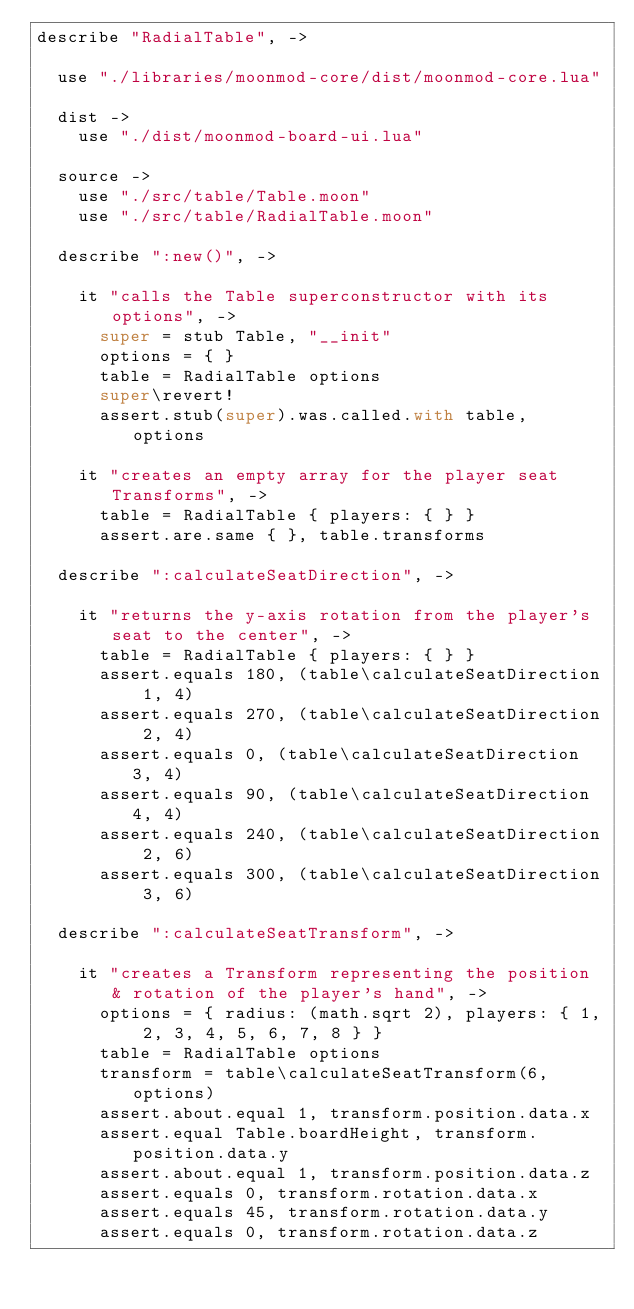<code> <loc_0><loc_0><loc_500><loc_500><_MoonScript_>describe "RadialTable", ->

  use "./libraries/moonmod-core/dist/moonmod-core.lua"

  dist ->
    use "./dist/moonmod-board-ui.lua"

  source ->
    use "./src/table/Table.moon"
    use "./src/table/RadialTable.moon"

  describe ":new()", ->

    it "calls the Table superconstructor with its options", ->
      super = stub Table, "__init"
      options = { }
      table = RadialTable options
      super\revert!
      assert.stub(super).was.called.with table, options

    it "creates an empty array for the player seat Transforms", ->
      table = RadialTable { players: { } }
      assert.are.same { }, table.transforms

  describe ":calculateSeatDirection", ->

    it "returns the y-axis rotation from the player's seat to the center", ->
      table = RadialTable { players: { } }
      assert.equals 180, (table\calculateSeatDirection 1, 4)
      assert.equals 270, (table\calculateSeatDirection 2, 4)
      assert.equals 0, (table\calculateSeatDirection 3, 4)
      assert.equals 90, (table\calculateSeatDirection 4, 4)
      assert.equals 240, (table\calculateSeatDirection 2, 6)
      assert.equals 300, (table\calculateSeatDirection 3, 6)

  describe ":calculateSeatTransform", ->

    it "creates a Transform representing the position & rotation of the player's hand", ->
      options = { radius: (math.sqrt 2), players: { 1, 2, 3, 4, 5, 6, 7, 8 } }
      table = RadialTable options
      transform = table\calculateSeatTransform(6, options)
      assert.about.equal 1, transform.position.data.x
      assert.equal Table.boardHeight, transform.position.data.y
      assert.about.equal 1, transform.position.data.z
      assert.equals 0, transform.rotation.data.x
      assert.equals 45, transform.rotation.data.y
      assert.equals 0, transform.rotation.data.z
</code> 